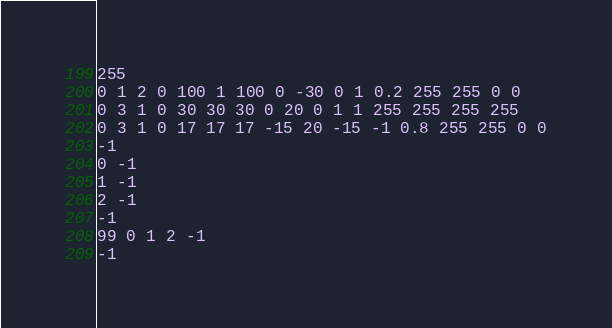Convert code to text. <code><loc_0><loc_0><loc_500><loc_500><_Scheme_>255
0 1 2 0 100 1 100 0 -30 0 1 0.2 255 255 0 0
0 3 1 0 30 30 30 0 20 0 1 1 255 255 255 255
0 3 1 0 17 17 17 -15 20 -15 -1 0.8 255 255 0 0
-1
0 -1
1 -1
2 -1
-1
99 0 1 2 -1
-1
</code> 